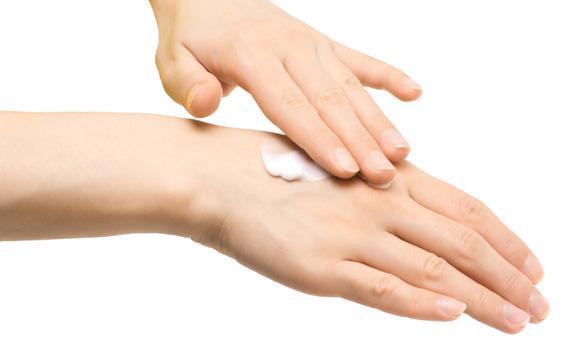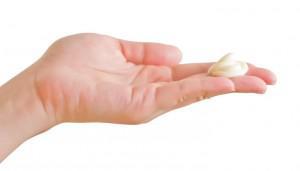The first image is the image on the left, the second image is the image on the right. For the images shown, is this caption "The left and right image contains a total of four hands with lotion being rubbed on the back of one hand." true? Answer yes or no. No. The first image is the image on the left, the second image is the image on the right. Assess this claim about the two images: "In one of the images, one hand has a glob of white lotion in the palm.". Correct or not? Answer yes or no. No. 